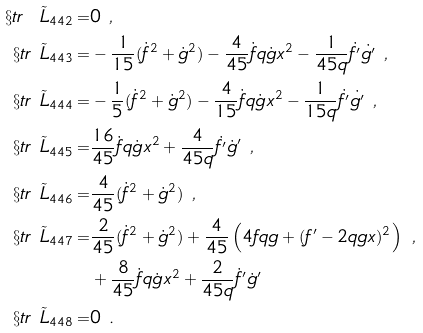Convert formula to latex. <formula><loc_0><loc_0><loc_500><loc_500>\S t r \ \tilde { L } _ { 4 4 2 } = & 0 \ , \\ \S t r \ \tilde { L } _ { 4 4 3 } = & - \frac { 1 } { 1 5 } ( \dot { f } ^ { 2 } + \dot { g } ^ { 2 } ) - \frac { 4 } { 4 5 } \dot { f } q \dot { g } x ^ { 2 } - \frac { 1 } { 4 5 q } \dot { f ^ { \prime } } \dot { g ^ { \prime } } \ , \\ \S t r \ \tilde { L } _ { 4 4 4 } = & - \frac { 1 } { 5 } ( \dot { f } ^ { 2 } + \dot { g } ^ { 2 } ) - \frac { 4 } { 1 5 } \dot { f } q \dot { g } x ^ { 2 } - \frac { 1 } { 1 5 q } \dot { f ^ { \prime } } \dot { g ^ { \prime } } \ , \\ \S t r \ \tilde { L } _ { 4 4 5 } = & \frac { 1 6 } { 4 5 } \dot { f } q \dot { g } x ^ { 2 } + \frac { 4 } { 4 5 q } \dot { f ^ { \prime } } \dot { g } ^ { \prime } \ , \\ \S t r \ \tilde { L } _ { 4 4 6 } = & \frac { 4 } { 4 5 } ( \dot { f } ^ { 2 } + \dot { g } ^ { 2 } ) \ , \\ \S t r \ \tilde { L } _ { 4 4 7 } = & \frac { 2 } { 4 5 } ( \dot { f } ^ { 2 } + \dot { g } ^ { 2 } ) + \frac { 4 } { 4 5 } \left ( 4 f q g + ( f ^ { \prime } - 2 q g x ) ^ { 2 } \right ) \ , \\ & + \frac { 8 } { 4 5 } \dot { f } q \dot { g } x ^ { 2 } + \frac { 2 } { 4 5 q } \dot { f } ^ { \prime } \dot { g } ^ { \prime } \\ \S t r \ \tilde { L } _ { 4 4 8 } = & 0 \ .</formula> 